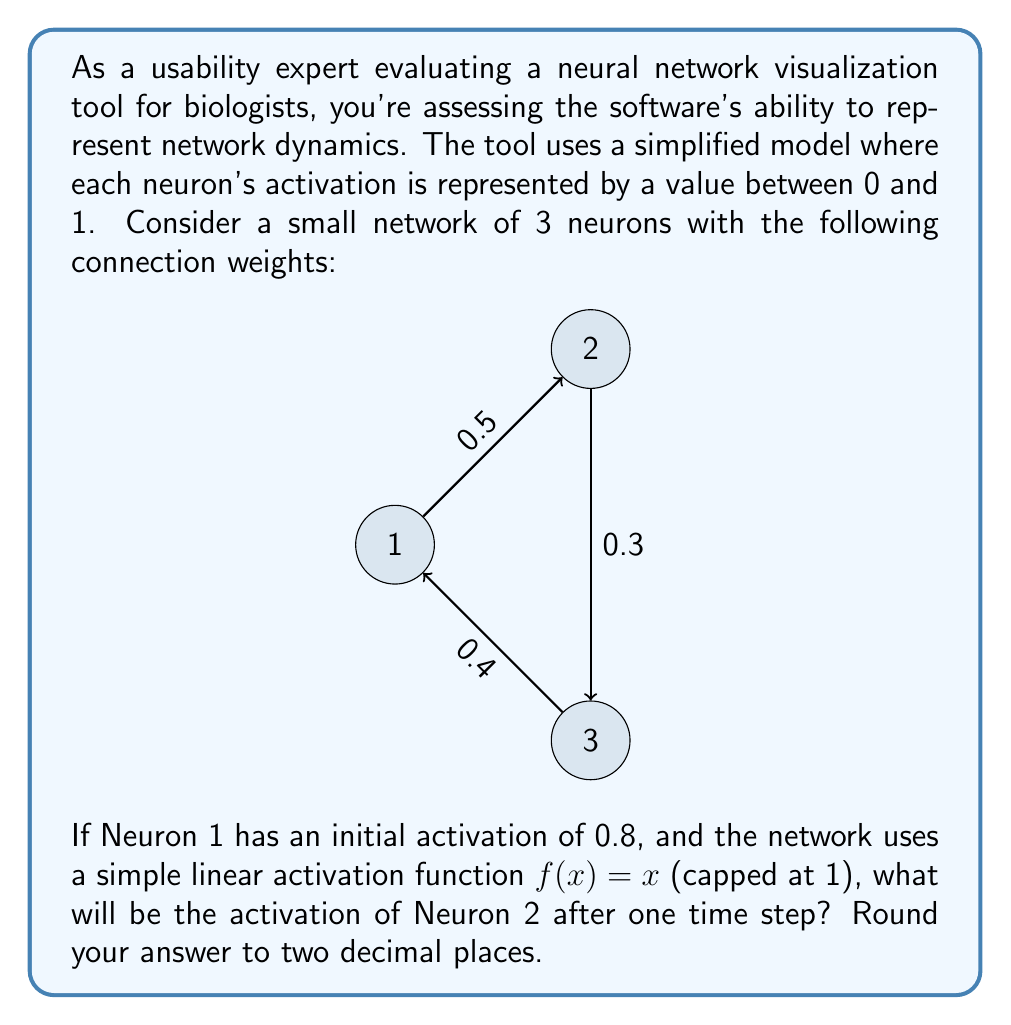Show me your answer to this math problem. To solve this problem, we'll follow these steps:

1) In a neural network, the activation of a neuron is typically calculated as the weighted sum of its inputs, passed through an activation function.

2) For Neuron 2, it receives input only from Neuron 1 in this time step.

3) The connection weight from Neuron 1 to Neuron 2 is 0.5.

4) The activation of Neuron 1 is 0.8.

5) The weighted input to Neuron 2 is therefore:

   $0.8 * 0.5 = 0.4$

6) This weighted input is then passed through the activation function. In this case, the activation function is the identity function $f(x) = x$, capped at 1.

7) Since 0.4 is less than 1, it remains unchanged by the activation function.

8) Therefore, the activation of Neuron 2 after one time step is 0.4.

9) The question asks for the answer rounded to two decimal places, which is still 0.40.

This simplified model allows for easy calculation and visualization of network dynamics, which is crucial for the usability of the tool for biologists who may not have extensive mathematical backgrounds.
Answer: 0.40 